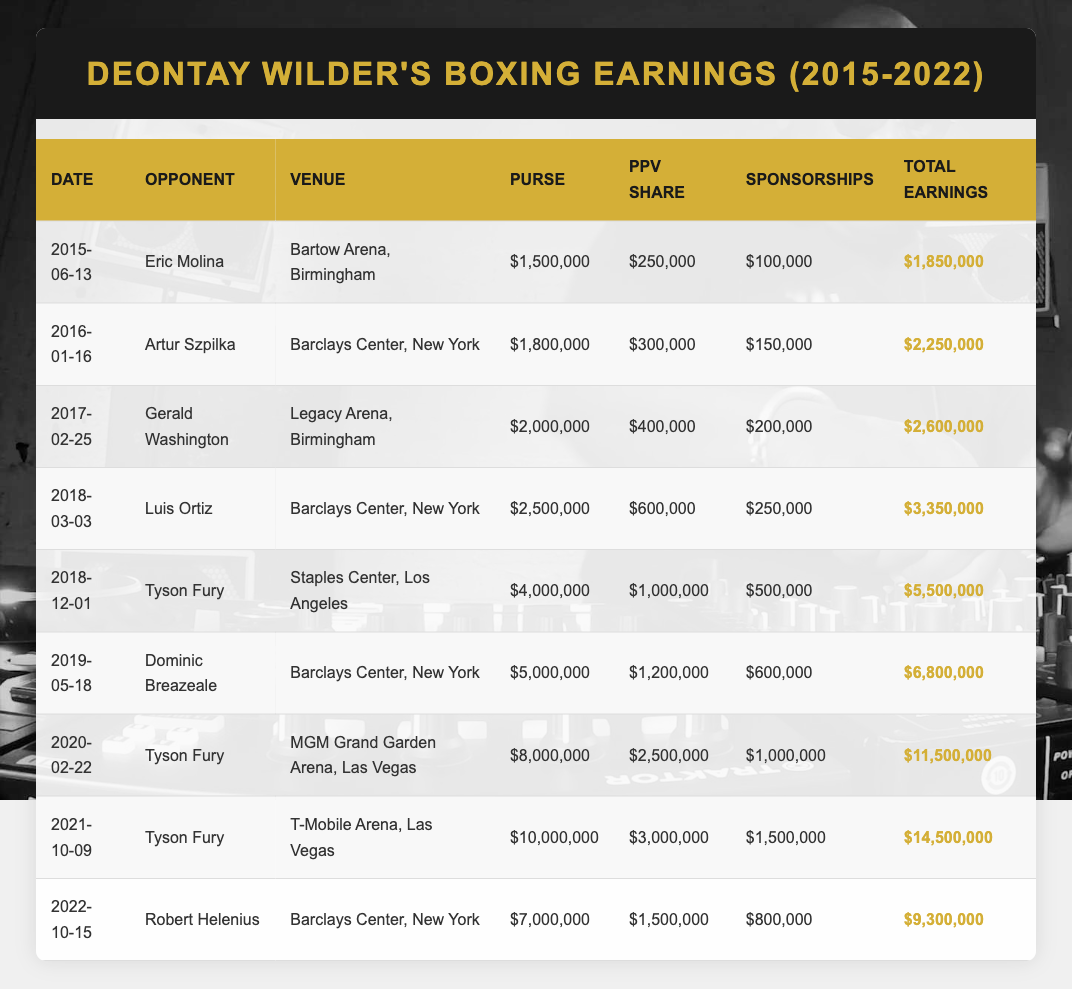What was Deontay Wilder's total earnings in the fight against Tyson Fury on December 1, 2018? In the table, the entry for the fight dated December 1, 2018, against Tyson Fury shows total earnings of 5,500,000.
Answer: 5,500,000 How much did Deontay Wilder earn from pay-per-view shares in the fight against Tyson Fury on February 22, 2020? In the table, for the fight on February 22, 2020, the PPV share listed is 2,500,000.
Answer: 2,500,000 What is the average total earnings for Deontay Wilder's fights against Tyson Fury? To find the average, we take the total earnings for the fights against Tyson Fury: 5,500,000 (2018) + 11,500,000 (2020) + 14,500,000 (2021) = 31,500,000. There are three fights, so the average is 31,500,000 / 3 = 10,500,000.
Answer: 10,500,000 Did Deontay Wilder earn more than 10 million dollars in total earnings for any fight? From the table, we can see that the fights on February 22, 2020, (11,500,000) and October 9, 2021, (14,500,000) both exceed 10 million dollars.
Answer: Yes What was the difference in total earnings between the fight against Dominic Breazeale on May 18, 2019, and the fight against Robert Helenius on October 15, 2022? The total earnings for the fight against Dominic Breazeale is 6,800,000, while the total for Robert Helenius is 9,300,000. The difference is calculated as 9,300,000 - 6,800,000 = 2,500,000.
Answer: 2,500,000 How many fights did Deontay Wilder have where he earned over 5 million dollars? By examining the total earnings, the fights with total earnings over 5 million dollars are: against Tyson Fury (3 fights), against Dominic Breazeale, and against Luis Ortiz. This totals to 6 fights.
Answer: 6 